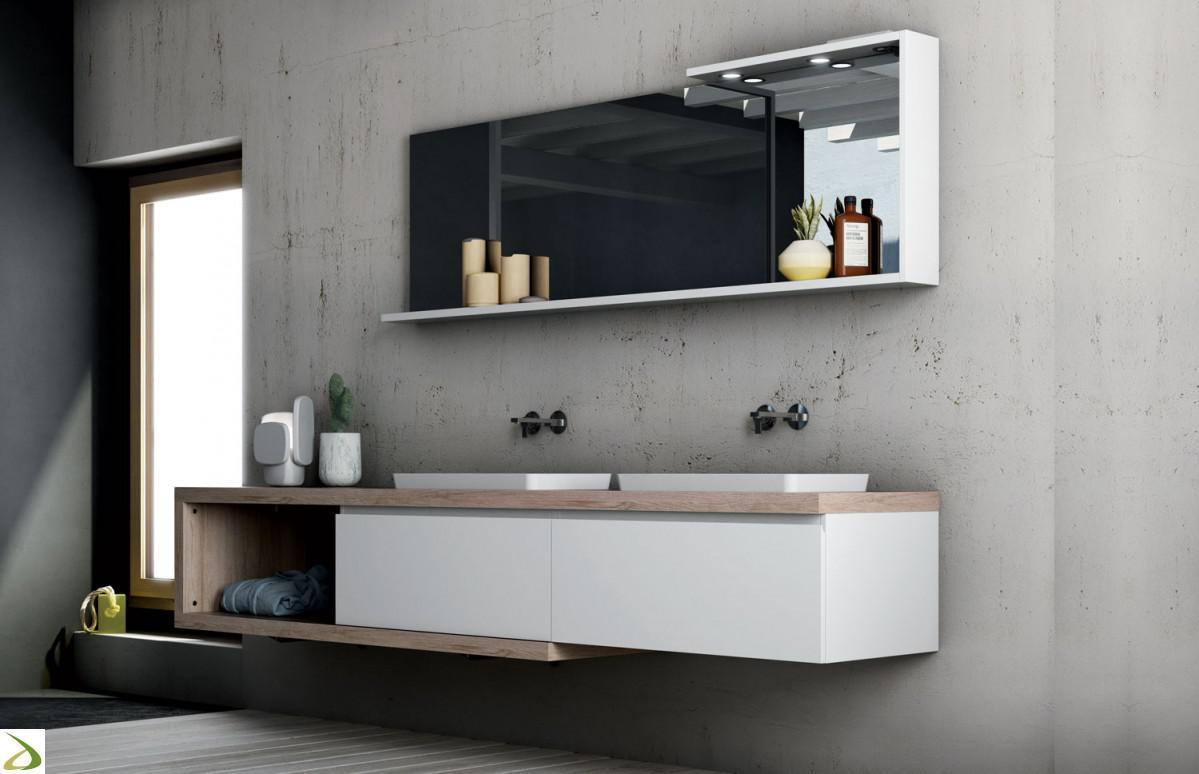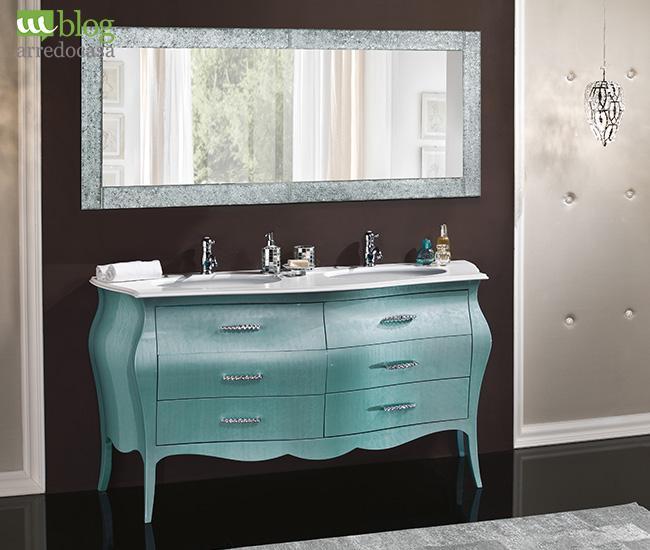The first image is the image on the left, the second image is the image on the right. Considering the images on both sides, is "An image shows a rectangular mirror above a rectangular double sinks on a white wall-mounted vanity, and one image features wall-mounted spouts above two sinks." valid? Answer yes or no. Yes. The first image is the image on the left, the second image is the image on the right. Assess this claim about the two images: "At least one of the images has a window.". Correct or not? Answer yes or no. Yes. 